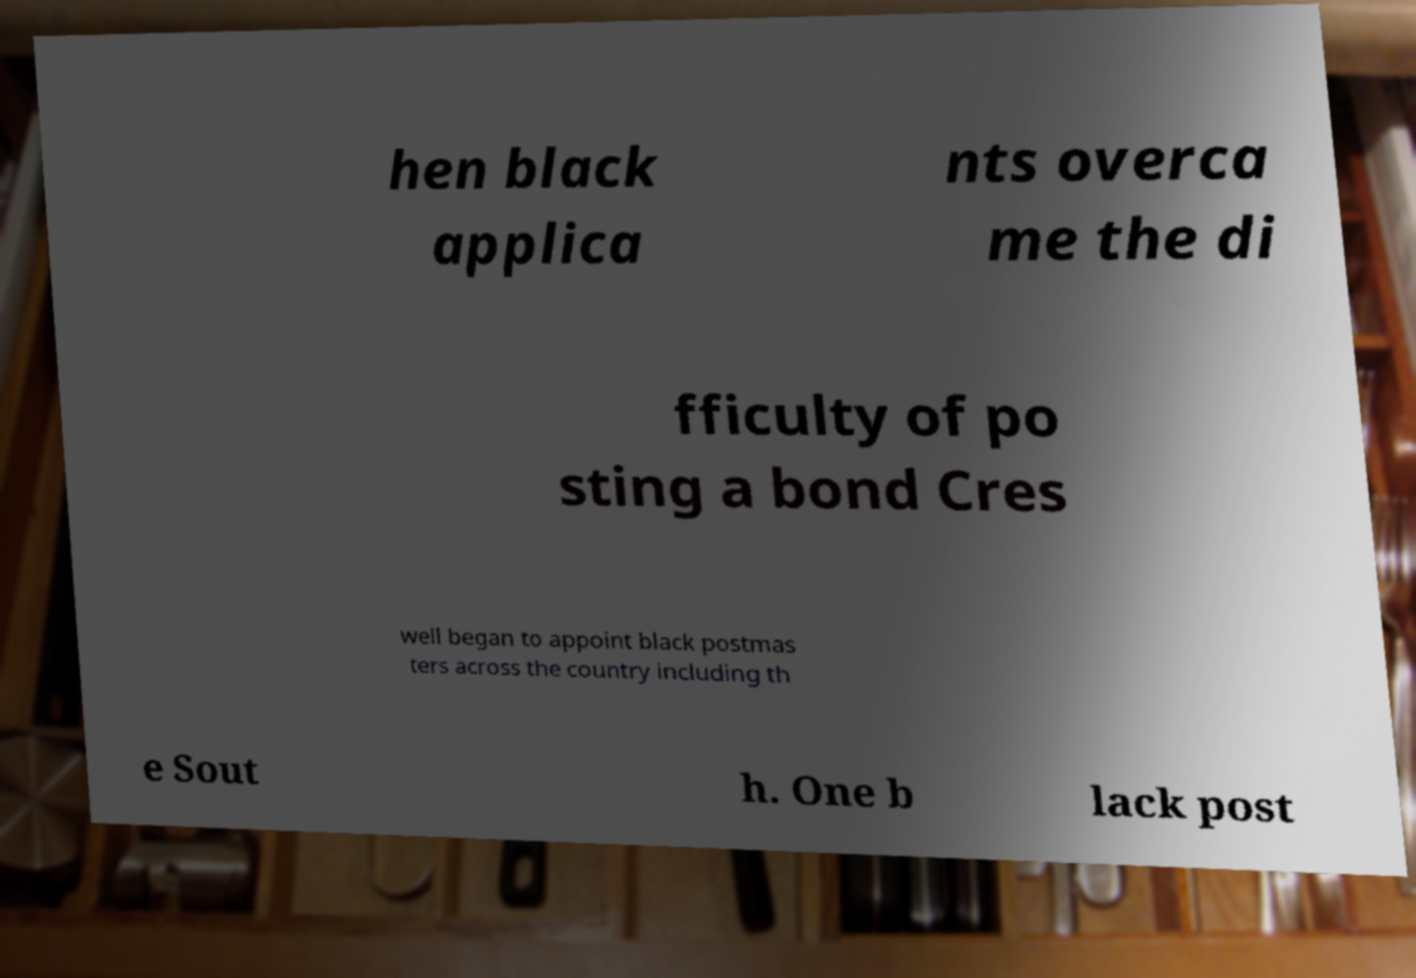I need the written content from this picture converted into text. Can you do that? hen black applica nts overca me the di fficulty of po sting a bond Cres well began to appoint black postmas ters across the country including th e Sout h. One b lack post 